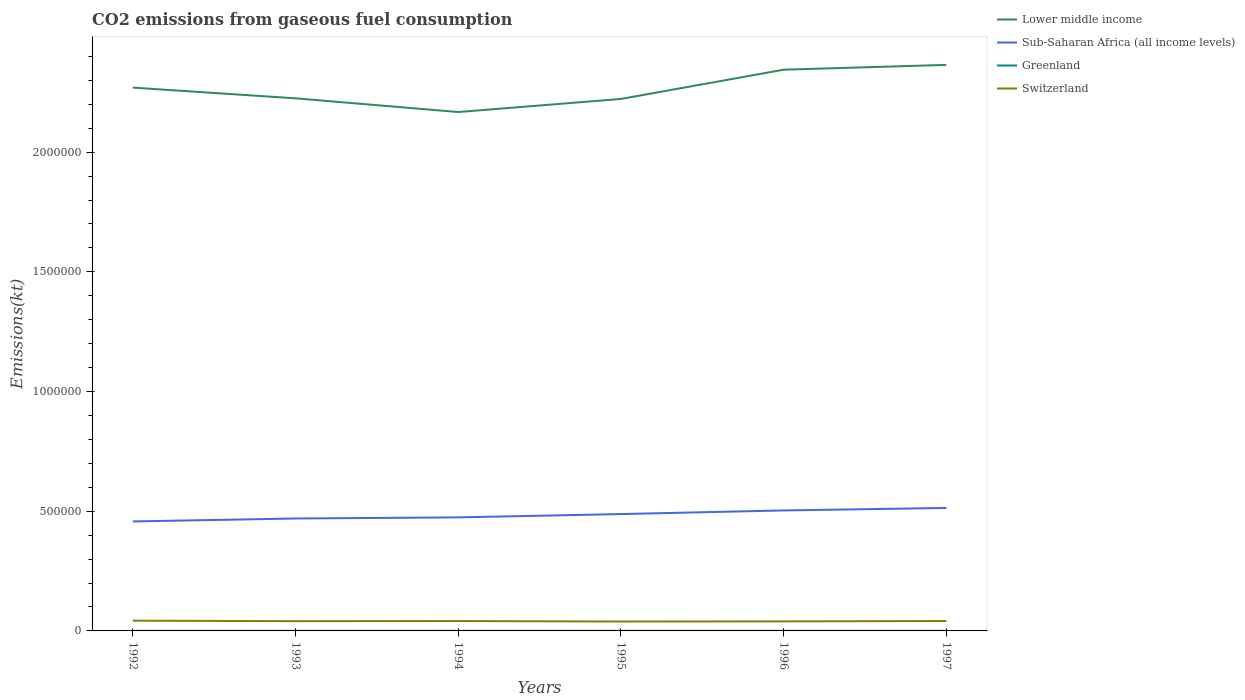How many different coloured lines are there?
Ensure brevity in your answer.  4. Across all years, what is the maximum amount of CO2 emitted in Switzerland?
Your answer should be compact. 3.92e+04. In which year was the amount of CO2 emitted in Switzerland maximum?
Your answer should be very brief. 1995. What is the total amount of CO2 emitted in Switzerland in the graph?
Your answer should be very brief. -143.01. What is the difference between the highest and the second highest amount of CO2 emitted in Switzerland?
Provide a succinct answer. 3567.99. What is the difference between the highest and the lowest amount of CO2 emitted in Lower middle income?
Your answer should be compact. 3. Are the values on the major ticks of Y-axis written in scientific E-notation?
Ensure brevity in your answer.  No. Where does the legend appear in the graph?
Your answer should be compact. Top right. How many legend labels are there?
Offer a terse response. 4. How are the legend labels stacked?
Provide a succinct answer. Vertical. What is the title of the graph?
Your answer should be very brief. CO2 emissions from gaseous fuel consumption. What is the label or title of the Y-axis?
Provide a short and direct response. Emissions(kt). What is the Emissions(kt) in Lower middle income in 1992?
Your answer should be compact. 2.27e+06. What is the Emissions(kt) in Sub-Saharan Africa (all income levels) in 1992?
Offer a very short reply. 4.57e+05. What is the Emissions(kt) of Greenland in 1992?
Provide a succinct answer. 484.04. What is the Emissions(kt) in Switzerland in 1992?
Provide a succinct answer. 4.28e+04. What is the Emissions(kt) in Lower middle income in 1993?
Make the answer very short. 2.22e+06. What is the Emissions(kt) of Sub-Saharan Africa (all income levels) in 1993?
Offer a very short reply. 4.70e+05. What is the Emissions(kt) in Greenland in 1993?
Ensure brevity in your answer.  502.38. What is the Emissions(kt) in Switzerland in 1993?
Provide a short and direct response. 4.08e+04. What is the Emissions(kt) of Lower middle income in 1994?
Ensure brevity in your answer.  2.17e+06. What is the Emissions(kt) in Sub-Saharan Africa (all income levels) in 1994?
Your answer should be compact. 4.74e+05. What is the Emissions(kt) in Greenland in 1994?
Give a very brief answer. 506.05. What is the Emissions(kt) of Switzerland in 1994?
Ensure brevity in your answer.  4.13e+04. What is the Emissions(kt) in Lower middle income in 1995?
Keep it short and to the point. 2.22e+06. What is the Emissions(kt) of Sub-Saharan Africa (all income levels) in 1995?
Offer a very short reply. 4.88e+05. What is the Emissions(kt) in Greenland in 1995?
Your answer should be very brief. 506.05. What is the Emissions(kt) of Switzerland in 1995?
Your answer should be very brief. 3.92e+04. What is the Emissions(kt) of Lower middle income in 1996?
Provide a succinct answer. 2.34e+06. What is the Emissions(kt) of Sub-Saharan Africa (all income levels) in 1996?
Offer a very short reply. 5.03e+05. What is the Emissions(kt) in Greenland in 1996?
Provide a short and direct response. 517.05. What is the Emissions(kt) in Switzerland in 1996?
Ensure brevity in your answer.  3.99e+04. What is the Emissions(kt) of Lower middle income in 1997?
Make the answer very short. 2.36e+06. What is the Emissions(kt) of Sub-Saharan Africa (all income levels) in 1997?
Provide a short and direct response. 5.14e+05. What is the Emissions(kt) of Greenland in 1997?
Give a very brief answer. 524.38. What is the Emissions(kt) of Switzerland in 1997?
Offer a terse response. 4.15e+04. Across all years, what is the maximum Emissions(kt) in Lower middle income?
Your response must be concise. 2.36e+06. Across all years, what is the maximum Emissions(kt) in Sub-Saharan Africa (all income levels)?
Provide a succinct answer. 5.14e+05. Across all years, what is the maximum Emissions(kt) of Greenland?
Provide a short and direct response. 524.38. Across all years, what is the maximum Emissions(kt) in Switzerland?
Offer a very short reply. 4.28e+04. Across all years, what is the minimum Emissions(kt) in Lower middle income?
Provide a short and direct response. 2.17e+06. Across all years, what is the minimum Emissions(kt) in Sub-Saharan Africa (all income levels)?
Offer a very short reply. 4.57e+05. Across all years, what is the minimum Emissions(kt) of Greenland?
Your answer should be very brief. 484.04. Across all years, what is the minimum Emissions(kt) in Switzerland?
Give a very brief answer. 3.92e+04. What is the total Emissions(kt) in Lower middle income in the graph?
Make the answer very short. 1.36e+07. What is the total Emissions(kt) of Sub-Saharan Africa (all income levels) in the graph?
Offer a terse response. 2.91e+06. What is the total Emissions(kt) in Greenland in the graph?
Your answer should be very brief. 3039.94. What is the total Emissions(kt) in Switzerland in the graph?
Your response must be concise. 2.45e+05. What is the difference between the Emissions(kt) of Lower middle income in 1992 and that in 1993?
Keep it short and to the point. 4.48e+04. What is the difference between the Emissions(kt) of Sub-Saharan Africa (all income levels) in 1992 and that in 1993?
Give a very brief answer. -1.22e+04. What is the difference between the Emissions(kt) in Greenland in 1992 and that in 1993?
Provide a short and direct response. -18.34. What is the difference between the Emissions(kt) in Switzerland in 1992 and that in 1993?
Provide a short and direct response. 2042.52. What is the difference between the Emissions(kt) in Lower middle income in 1992 and that in 1994?
Your response must be concise. 1.02e+05. What is the difference between the Emissions(kt) of Sub-Saharan Africa (all income levels) in 1992 and that in 1994?
Give a very brief answer. -1.69e+04. What is the difference between the Emissions(kt) of Greenland in 1992 and that in 1994?
Provide a succinct answer. -22. What is the difference between the Emissions(kt) of Switzerland in 1992 and that in 1994?
Make the answer very short. 1470.47. What is the difference between the Emissions(kt) of Lower middle income in 1992 and that in 1995?
Offer a very short reply. 4.74e+04. What is the difference between the Emissions(kt) in Sub-Saharan Africa (all income levels) in 1992 and that in 1995?
Your response must be concise. -3.08e+04. What is the difference between the Emissions(kt) in Greenland in 1992 and that in 1995?
Ensure brevity in your answer.  -22. What is the difference between the Emissions(kt) of Switzerland in 1992 and that in 1995?
Provide a succinct answer. 3567.99. What is the difference between the Emissions(kt) of Lower middle income in 1992 and that in 1996?
Make the answer very short. -7.47e+04. What is the difference between the Emissions(kt) in Sub-Saharan Africa (all income levels) in 1992 and that in 1996?
Your response must be concise. -4.59e+04. What is the difference between the Emissions(kt) in Greenland in 1992 and that in 1996?
Offer a terse response. -33. What is the difference between the Emissions(kt) in Switzerland in 1992 and that in 1996?
Give a very brief answer. 2907.93. What is the difference between the Emissions(kt) in Lower middle income in 1992 and that in 1997?
Your answer should be compact. -9.50e+04. What is the difference between the Emissions(kt) of Sub-Saharan Africa (all income levels) in 1992 and that in 1997?
Offer a very short reply. -5.63e+04. What is the difference between the Emissions(kt) of Greenland in 1992 and that in 1997?
Your response must be concise. -40.34. What is the difference between the Emissions(kt) of Switzerland in 1992 and that in 1997?
Offer a very short reply. 1327.45. What is the difference between the Emissions(kt) in Lower middle income in 1993 and that in 1994?
Your response must be concise. 5.73e+04. What is the difference between the Emissions(kt) in Sub-Saharan Africa (all income levels) in 1993 and that in 1994?
Your answer should be very brief. -4729.34. What is the difference between the Emissions(kt) in Greenland in 1993 and that in 1994?
Provide a short and direct response. -3.67. What is the difference between the Emissions(kt) in Switzerland in 1993 and that in 1994?
Offer a terse response. -572.05. What is the difference between the Emissions(kt) in Lower middle income in 1993 and that in 1995?
Provide a succinct answer. 2577.5. What is the difference between the Emissions(kt) of Sub-Saharan Africa (all income levels) in 1993 and that in 1995?
Give a very brief answer. -1.86e+04. What is the difference between the Emissions(kt) of Greenland in 1993 and that in 1995?
Ensure brevity in your answer.  -3.67. What is the difference between the Emissions(kt) of Switzerland in 1993 and that in 1995?
Keep it short and to the point. 1525.47. What is the difference between the Emissions(kt) in Lower middle income in 1993 and that in 1996?
Provide a succinct answer. -1.20e+05. What is the difference between the Emissions(kt) of Sub-Saharan Africa (all income levels) in 1993 and that in 1996?
Offer a very short reply. -3.37e+04. What is the difference between the Emissions(kt) of Greenland in 1993 and that in 1996?
Provide a succinct answer. -14.67. What is the difference between the Emissions(kt) in Switzerland in 1993 and that in 1996?
Your response must be concise. 865.41. What is the difference between the Emissions(kt) in Lower middle income in 1993 and that in 1997?
Keep it short and to the point. -1.40e+05. What is the difference between the Emissions(kt) in Sub-Saharan Africa (all income levels) in 1993 and that in 1997?
Offer a terse response. -4.41e+04. What is the difference between the Emissions(kt) in Greenland in 1993 and that in 1997?
Give a very brief answer. -22. What is the difference between the Emissions(kt) in Switzerland in 1993 and that in 1997?
Provide a succinct answer. -715.07. What is the difference between the Emissions(kt) in Lower middle income in 1994 and that in 1995?
Provide a succinct answer. -5.47e+04. What is the difference between the Emissions(kt) in Sub-Saharan Africa (all income levels) in 1994 and that in 1995?
Ensure brevity in your answer.  -1.39e+04. What is the difference between the Emissions(kt) in Switzerland in 1994 and that in 1995?
Make the answer very short. 2097.52. What is the difference between the Emissions(kt) in Lower middle income in 1994 and that in 1996?
Provide a short and direct response. -1.77e+05. What is the difference between the Emissions(kt) of Sub-Saharan Africa (all income levels) in 1994 and that in 1996?
Offer a very short reply. -2.90e+04. What is the difference between the Emissions(kt) in Greenland in 1994 and that in 1996?
Ensure brevity in your answer.  -11. What is the difference between the Emissions(kt) in Switzerland in 1994 and that in 1996?
Offer a terse response. 1437.46. What is the difference between the Emissions(kt) in Lower middle income in 1994 and that in 1997?
Make the answer very short. -1.97e+05. What is the difference between the Emissions(kt) in Sub-Saharan Africa (all income levels) in 1994 and that in 1997?
Make the answer very short. -3.93e+04. What is the difference between the Emissions(kt) of Greenland in 1994 and that in 1997?
Offer a very short reply. -18.34. What is the difference between the Emissions(kt) in Switzerland in 1994 and that in 1997?
Provide a short and direct response. -143.01. What is the difference between the Emissions(kt) in Lower middle income in 1995 and that in 1996?
Provide a succinct answer. -1.22e+05. What is the difference between the Emissions(kt) of Sub-Saharan Africa (all income levels) in 1995 and that in 1996?
Provide a succinct answer. -1.52e+04. What is the difference between the Emissions(kt) in Greenland in 1995 and that in 1996?
Your answer should be very brief. -11. What is the difference between the Emissions(kt) of Switzerland in 1995 and that in 1996?
Your response must be concise. -660.06. What is the difference between the Emissions(kt) of Lower middle income in 1995 and that in 1997?
Your answer should be very brief. -1.42e+05. What is the difference between the Emissions(kt) in Sub-Saharan Africa (all income levels) in 1995 and that in 1997?
Your response must be concise. -2.55e+04. What is the difference between the Emissions(kt) of Greenland in 1995 and that in 1997?
Offer a terse response. -18.34. What is the difference between the Emissions(kt) of Switzerland in 1995 and that in 1997?
Give a very brief answer. -2240.54. What is the difference between the Emissions(kt) of Lower middle income in 1996 and that in 1997?
Make the answer very short. -2.02e+04. What is the difference between the Emissions(kt) of Sub-Saharan Africa (all income levels) in 1996 and that in 1997?
Your answer should be compact. -1.03e+04. What is the difference between the Emissions(kt) in Greenland in 1996 and that in 1997?
Make the answer very short. -7.33. What is the difference between the Emissions(kt) in Switzerland in 1996 and that in 1997?
Provide a short and direct response. -1580.48. What is the difference between the Emissions(kt) in Lower middle income in 1992 and the Emissions(kt) in Sub-Saharan Africa (all income levels) in 1993?
Your answer should be compact. 1.80e+06. What is the difference between the Emissions(kt) in Lower middle income in 1992 and the Emissions(kt) in Greenland in 1993?
Ensure brevity in your answer.  2.27e+06. What is the difference between the Emissions(kt) in Lower middle income in 1992 and the Emissions(kt) in Switzerland in 1993?
Offer a terse response. 2.23e+06. What is the difference between the Emissions(kt) in Sub-Saharan Africa (all income levels) in 1992 and the Emissions(kt) in Greenland in 1993?
Give a very brief answer. 4.57e+05. What is the difference between the Emissions(kt) of Sub-Saharan Africa (all income levels) in 1992 and the Emissions(kt) of Switzerland in 1993?
Your response must be concise. 4.17e+05. What is the difference between the Emissions(kt) in Greenland in 1992 and the Emissions(kt) in Switzerland in 1993?
Your answer should be very brief. -4.03e+04. What is the difference between the Emissions(kt) of Lower middle income in 1992 and the Emissions(kt) of Sub-Saharan Africa (all income levels) in 1994?
Your response must be concise. 1.80e+06. What is the difference between the Emissions(kt) of Lower middle income in 1992 and the Emissions(kt) of Greenland in 1994?
Offer a terse response. 2.27e+06. What is the difference between the Emissions(kt) of Lower middle income in 1992 and the Emissions(kt) of Switzerland in 1994?
Provide a short and direct response. 2.23e+06. What is the difference between the Emissions(kt) of Sub-Saharan Africa (all income levels) in 1992 and the Emissions(kt) of Greenland in 1994?
Ensure brevity in your answer.  4.57e+05. What is the difference between the Emissions(kt) in Sub-Saharan Africa (all income levels) in 1992 and the Emissions(kt) in Switzerland in 1994?
Offer a very short reply. 4.16e+05. What is the difference between the Emissions(kt) in Greenland in 1992 and the Emissions(kt) in Switzerland in 1994?
Your answer should be very brief. -4.08e+04. What is the difference between the Emissions(kt) of Lower middle income in 1992 and the Emissions(kt) of Sub-Saharan Africa (all income levels) in 1995?
Your answer should be compact. 1.78e+06. What is the difference between the Emissions(kt) in Lower middle income in 1992 and the Emissions(kt) in Greenland in 1995?
Keep it short and to the point. 2.27e+06. What is the difference between the Emissions(kt) of Lower middle income in 1992 and the Emissions(kt) of Switzerland in 1995?
Keep it short and to the point. 2.23e+06. What is the difference between the Emissions(kt) in Sub-Saharan Africa (all income levels) in 1992 and the Emissions(kt) in Greenland in 1995?
Your answer should be very brief. 4.57e+05. What is the difference between the Emissions(kt) in Sub-Saharan Africa (all income levels) in 1992 and the Emissions(kt) in Switzerland in 1995?
Offer a terse response. 4.18e+05. What is the difference between the Emissions(kt) of Greenland in 1992 and the Emissions(kt) of Switzerland in 1995?
Offer a terse response. -3.87e+04. What is the difference between the Emissions(kt) of Lower middle income in 1992 and the Emissions(kt) of Sub-Saharan Africa (all income levels) in 1996?
Offer a very short reply. 1.77e+06. What is the difference between the Emissions(kt) in Lower middle income in 1992 and the Emissions(kt) in Greenland in 1996?
Offer a very short reply. 2.27e+06. What is the difference between the Emissions(kt) of Lower middle income in 1992 and the Emissions(kt) of Switzerland in 1996?
Provide a short and direct response. 2.23e+06. What is the difference between the Emissions(kt) in Sub-Saharan Africa (all income levels) in 1992 and the Emissions(kt) in Greenland in 1996?
Offer a terse response. 4.57e+05. What is the difference between the Emissions(kt) in Sub-Saharan Africa (all income levels) in 1992 and the Emissions(kt) in Switzerland in 1996?
Offer a very short reply. 4.17e+05. What is the difference between the Emissions(kt) in Greenland in 1992 and the Emissions(kt) in Switzerland in 1996?
Your answer should be compact. -3.94e+04. What is the difference between the Emissions(kt) of Lower middle income in 1992 and the Emissions(kt) of Sub-Saharan Africa (all income levels) in 1997?
Ensure brevity in your answer.  1.76e+06. What is the difference between the Emissions(kt) of Lower middle income in 1992 and the Emissions(kt) of Greenland in 1997?
Provide a succinct answer. 2.27e+06. What is the difference between the Emissions(kt) of Lower middle income in 1992 and the Emissions(kt) of Switzerland in 1997?
Provide a short and direct response. 2.23e+06. What is the difference between the Emissions(kt) of Sub-Saharan Africa (all income levels) in 1992 and the Emissions(kt) of Greenland in 1997?
Your answer should be very brief. 4.57e+05. What is the difference between the Emissions(kt) of Sub-Saharan Africa (all income levels) in 1992 and the Emissions(kt) of Switzerland in 1997?
Provide a short and direct response. 4.16e+05. What is the difference between the Emissions(kt) of Greenland in 1992 and the Emissions(kt) of Switzerland in 1997?
Your answer should be very brief. -4.10e+04. What is the difference between the Emissions(kt) in Lower middle income in 1993 and the Emissions(kt) in Sub-Saharan Africa (all income levels) in 1994?
Your response must be concise. 1.75e+06. What is the difference between the Emissions(kt) in Lower middle income in 1993 and the Emissions(kt) in Greenland in 1994?
Keep it short and to the point. 2.22e+06. What is the difference between the Emissions(kt) of Lower middle income in 1993 and the Emissions(kt) of Switzerland in 1994?
Make the answer very short. 2.18e+06. What is the difference between the Emissions(kt) in Sub-Saharan Africa (all income levels) in 1993 and the Emissions(kt) in Greenland in 1994?
Keep it short and to the point. 4.69e+05. What is the difference between the Emissions(kt) in Sub-Saharan Africa (all income levels) in 1993 and the Emissions(kt) in Switzerland in 1994?
Make the answer very short. 4.28e+05. What is the difference between the Emissions(kt) in Greenland in 1993 and the Emissions(kt) in Switzerland in 1994?
Ensure brevity in your answer.  -4.08e+04. What is the difference between the Emissions(kt) of Lower middle income in 1993 and the Emissions(kt) of Sub-Saharan Africa (all income levels) in 1995?
Your response must be concise. 1.74e+06. What is the difference between the Emissions(kt) of Lower middle income in 1993 and the Emissions(kt) of Greenland in 1995?
Offer a terse response. 2.22e+06. What is the difference between the Emissions(kt) in Lower middle income in 1993 and the Emissions(kt) in Switzerland in 1995?
Your answer should be compact. 2.19e+06. What is the difference between the Emissions(kt) of Sub-Saharan Africa (all income levels) in 1993 and the Emissions(kt) of Greenland in 1995?
Make the answer very short. 4.69e+05. What is the difference between the Emissions(kt) of Sub-Saharan Africa (all income levels) in 1993 and the Emissions(kt) of Switzerland in 1995?
Your answer should be compact. 4.30e+05. What is the difference between the Emissions(kt) in Greenland in 1993 and the Emissions(kt) in Switzerland in 1995?
Keep it short and to the point. -3.87e+04. What is the difference between the Emissions(kt) in Lower middle income in 1993 and the Emissions(kt) in Sub-Saharan Africa (all income levels) in 1996?
Your answer should be very brief. 1.72e+06. What is the difference between the Emissions(kt) of Lower middle income in 1993 and the Emissions(kt) of Greenland in 1996?
Keep it short and to the point. 2.22e+06. What is the difference between the Emissions(kt) in Lower middle income in 1993 and the Emissions(kt) in Switzerland in 1996?
Your response must be concise. 2.18e+06. What is the difference between the Emissions(kt) in Sub-Saharan Africa (all income levels) in 1993 and the Emissions(kt) in Greenland in 1996?
Offer a very short reply. 4.69e+05. What is the difference between the Emissions(kt) in Sub-Saharan Africa (all income levels) in 1993 and the Emissions(kt) in Switzerland in 1996?
Keep it short and to the point. 4.30e+05. What is the difference between the Emissions(kt) of Greenland in 1993 and the Emissions(kt) of Switzerland in 1996?
Provide a short and direct response. -3.94e+04. What is the difference between the Emissions(kt) in Lower middle income in 1993 and the Emissions(kt) in Sub-Saharan Africa (all income levels) in 1997?
Offer a terse response. 1.71e+06. What is the difference between the Emissions(kt) of Lower middle income in 1993 and the Emissions(kt) of Greenland in 1997?
Make the answer very short. 2.22e+06. What is the difference between the Emissions(kt) in Lower middle income in 1993 and the Emissions(kt) in Switzerland in 1997?
Provide a succinct answer. 2.18e+06. What is the difference between the Emissions(kt) in Sub-Saharan Africa (all income levels) in 1993 and the Emissions(kt) in Greenland in 1997?
Offer a terse response. 4.69e+05. What is the difference between the Emissions(kt) of Sub-Saharan Africa (all income levels) in 1993 and the Emissions(kt) of Switzerland in 1997?
Offer a terse response. 4.28e+05. What is the difference between the Emissions(kt) in Greenland in 1993 and the Emissions(kt) in Switzerland in 1997?
Provide a succinct answer. -4.10e+04. What is the difference between the Emissions(kt) of Lower middle income in 1994 and the Emissions(kt) of Sub-Saharan Africa (all income levels) in 1995?
Offer a very short reply. 1.68e+06. What is the difference between the Emissions(kt) in Lower middle income in 1994 and the Emissions(kt) in Greenland in 1995?
Ensure brevity in your answer.  2.17e+06. What is the difference between the Emissions(kt) in Lower middle income in 1994 and the Emissions(kt) in Switzerland in 1995?
Give a very brief answer. 2.13e+06. What is the difference between the Emissions(kt) in Sub-Saharan Africa (all income levels) in 1994 and the Emissions(kt) in Greenland in 1995?
Ensure brevity in your answer.  4.74e+05. What is the difference between the Emissions(kt) in Sub-Saharan Africa (all income levels) in 1994 and the Emissions(kt) in Switzerland in 1995?
Provide a short and direct response. 4.35e+05. What is the difference between the Emissions(kt) in Greenland in 1994 and the Emissions(kt) in Switzerland in 1995?
Make the answer very short. -3.87e+04. What is the difference between the Emissions(kt) of Lower middle income in 1994 and the Emissions(kt) of Sub-Saharan Africa (all income levels) in 1996?
Provide a short and direct response. 1.66e+06. What is the difference between the Emissions(kt) of Lower middle income in 1994 and the Emissions(kt) of Greenland in 1996?
Ensure brevity in your answer.  2.17e+06. What is the difference between the Emissions(kt) in Lower middle income in 1994 and the Emissions(kt) in Switzerland in 1996?
Provide a succinct answer. 2.13e+06. What is the difference between the Emissions(kt) of Sub-Saharan Africa (all income levels) in 1994 and the Emissions(kt) of Greenland in 1996?
Provide a short and direct response. 4.74e+05. What is the difference between the Emissions(kt) of Sub-Saharan Africa (all income levels) in 1994 and the Emissions(kt) of Switzerland in 1996?
Keep it short and to the point. 4.34e+05. What is the difference between the Emissions(kt) of Greenland in 1994 and the Emissions(kt) of Switzerland in 1996?
Provide a short and direct response. -3.94e+04. What is the difference between the Emissions(kt) in Lower middle income in 1994 and the Emissions(kt) in Sub-Saharan Africa (all income levels) in 1997?
Offer a very short reply. 1.65e+06. What is the difference between the Emissions(kt) of Lower middle income in 1994 and the Emissions(kt) of Greenland in 1997?
Your response must be concise. 2.17e+06. What is the difference between the Emissions(kt) of Lower middle income in 1994 and the Emissions(kt) of Switzerland in 1997?
Keep it short and to the point. 2.13e+06. What is the difference between the Emissions(kt) of Sub-Saharan Africa (all income levels) in 1994 and the Emissions(kt) of Greenland in 1997?
Keep it short and to the point. 4.74e+05. What is the difference between the Emissions(kt) in Sub-Saharan Africa (all income levels) in 1994 and the Emissions(kt) in Switzerland in 1997?
Ensure brevity in your answer.  4.33e+05. What is the difference between the Emissions(kt) in Greenland in 1994 and the Emissions(kt) in Switzerland in 1997?
Provide a short and direct response. -4.10e+04. What is the difference between the Emissions(kt) in Lower middle income in 1995 and the Emissions(kt) in Sub-Saharan Africa (all income levels) in 1996?
Offer a terse response. 1.72e+06. What is the difference between the Emissions(kt) of Lower middle income in 1995 and the Emissions(kt) of Greenland in 1996?
Offer a very short reply. 2.22e+06. What is the difference between the Emissions(kt) in Lower middle income in 1995 and the Emissions(kt) in Switzerland in 1996?
Provide a short and direct response. 2.18e+06. What is the difference between the Emissions(kt) in Sub-Saharan Africa (all income levels) in 1995 and the Emissions(kt) in Greenland in 1996?
Your response must be concise. 4.88e+05. What is the difference between the Emissions(kt) in Sub-Saharan Africa (all income levels) in 1995 and the Emissions(kt) in Switzerland in 1996?
Your response must be concise. 4.48e+05. What is the difference between the Emissions(kt) of Greenland in 1995 and the Emissions(kt) of Switzerland in 1996?
Give a very brief answer. -3.94e+04. What is the difference between the Emissions(kt) of Lower middle income in 1995 and the Emissions(kt) of Sub-Saharan Africa (all income levels) in 1997?
Offer a terse response. 1.71e+06. What is the difference between the Emissions(kt) in Lower middle income in 1995 and the Emissions(kt) in Greenland in 1997?
Provide a succinct answer. 2.22e+06. What is the difference between the Emissions(kt) in Lower middle income in 1995 and the Emissions(kt) in Switzerland in 1997?
Provide a succinct answer. 2.18e+06. What is the difference between the Emissions(kt) of Sub-Saharan Africa (all income levels) in 1995 and the Emissions(kt) of Greenland in 1997?
Offer a very short reply. 4.88e+05. What is the difference between the Emissions(kt) of Sub-Saharan Africa (all income levels) in 1995 and the Emissions(kt) of Switzerland in 1997?
Keep it short and to the point. 4.47e+05. What is the difference between the Emissions(kt) in Greenland in 1995 and the Emissions(kt) in Switzerland in 1997?
Make the answer very short. -4.10e+04. What is the difference between the Emissions(kt) of Lower middle income in 1996 and the Emissions(kt) of Sub-Saharan Africa (all income levels) in 1997?
Your answer should be very brief. 1.83e+06. What is the difference between the Emissions(kt) of Lower middle income in 1996 and the Emissions(kt) of Greenland in 1997?
Make the answer very short. 2.34e+06. What is the difference between the Emissions(kt) of Lower middle income in 1996 and the Emissions(kt) of Switzerland in 1997?
Make the answer very short. 2.30e+06. What is the difference between the Emissions(kt) of Sub-Saharan Africa (all income levels) in 1996 and the Emissions(kt) of Greenland in 1997?
Make the answer very short. 5.03e+05. What is the difference between the Emissions(kt) in Sub-Saharan Africa (all income levels) in 1996 and the Emissions(kt) in Switzerland in 1997?
Your response must be concise. 4.62e+05. What is the difference between the Emissions(kt) of Greenland in 1996 and the Emissions(kt) of Switzerland in 1997?
Give a very brief answer. -4.09e+04. What is the average Emissions(kt) of Lower middle income per year?
Your answer should be very brief. 2.27e+06. What is the average Emissions(kt) in Sub-Saharan Africa (all income levels) per year?
Offer a terse response. 4.84e+05. What is the average Emissions(kt) of Greenland per year?
Offer a terse response. 506.66. What is the average Emissions(kt) in Switzerland per year?
Make the answer very short. 4.09e+04. In the year 1992, what is the difference between the Emissions(kt) of Lower middle income and Emissions(kt) of Sub-Saharan Africa (all income levels)?
Your response must be concise. 1.81e+06. In the year 1992, what is the difference between the Emissions(kt) in Lower middle income and Emissions(kt) in Greenland?
Provide a short and direct response. 2.27e+06. In the year 1992, what is the difference between the Emissions(kt) of Lower middle income and Emissions(kt) of Switzerland?
Offer a very short reply. 2.23e+06. In the year 1992, what is the difference between the Emissions(kt) in Sub-Saharan Africa (all income levels) and Emissions(kt) in Greenland?
Provide a succinct answer. 4.57e+05. In the year 1992, what is the difference between the Emissions(kt) of Sub-Saharan Africa (all income levels) and Emissions(kt) of Switzerland?
Ensure brevity in your answer.  4.15e+05. In the year 1992, what is the difference between the Emissions(kt) of Greenland and Emissions(kt) of Switzerland?
Make the answer very short. -4.23e+04. In the year 1993, what is the difference between the Emissions(kt) of Lower middle income and Emissions(kt) of Sub-Saharan Africa (all income levels)?
Ensure brevity in your answer.  1.76e+06. In the year 1993, what is the difference between the Emissions(kt) of Lower middle income and Emissions(kt) of Greenland?
Give a very brief answer. 2.22e+06. In the year 1993, what is the difference between the Emissions(kt) of Lower middle income and Emissions(kt) of Switzerland?
Give a very brief answer. 2.18e+06. In the year 1993, what is the difference between the Emissions(kt) in Sub-Saharan Africa (all income levels) and Emissions(kt) in Greenland?
Your answer should be very brief. 4.69e+05. In the year 1993, what is the difference between the Emissions(kt) of Sub-Saharan Africa (all income levels) and Emissions(kt) of Switzerland?
Ensure brevity in your answer.  4.29e+05. In the year 1993, what is the difference between the Emissions(kt) in Greenland and Emissions(kt) in Switzerland?
Ensure brevity in your answer.  -4.02e+04. In the year 1994, what is the difference between the Emissions(kt) in Lower middle income and Emissions(kt) in Sub-Saharan Africa (all income levels)?
Your answer should be compact. 1.69e+06. In the year 1994, what is the difference between the Emissions(kt) of Lower middle income and Emissions(kt) of Greenland?
Offer a very short reply. 2.17e+06. In the year 1994, what is the difference between the Emissions(kt) in Lower middle income and Emissions(kt) in Switzerland?
Make the answer very short. 2.13e+06. In the year 1994, what is the difference between the Emissions(kt) in Sub-Saharan Africa (all income levels) and Emissions(kt) in Greenland?
Give a very brief answer. 4.74e+05. In the year 1994, what is the difference between the Emissions(kt) of Sub-Saharan Africa (all income levels) and Emissions(kt) of Switzerland?
Give a very brief answer. 4.33e+05. In the year 1994, what is the difference between the Emissions(kt) of Greenland and Emissions(kt) of Switzerland?
Offer a very short reply. -4.08e+04. In the year 1995, what is the difference between the Emissions(kt) in Lower middle income and Emissions(kt) in Sub-Saharan Africa (all income levels)?
Keep it short and to the point. 1.73e+06. In the year 1995, what is the difference between the Emissions(kt) of Lower middle income and Emissions(kt) of Greenland?
Offer a very short reply. 2.22e+06. In the year 1995, what is the difference between the Emissions(kt) of Lower middle income and Emissions(kt) of Switzerland?
Your answer should be compact. 2.18e+06. In the year 1995, what is the difference between the Emissions(kt) in Sub-Saharan Africa (all income levels) and Emissions(kt) in Greenland?
Offer a terse response. 4.88e+05. In the year 1995, what is the difference between the Emissions(kt) in Sub-Saharan Africa (all income levels) and Emissions(kt) in Switzerland?
Give a very brief answer. 4.49e+05. In the year 1995, what is the difference between the Emissions(kt) of Greenland and Emissions(kt) of Switzerland?
Your answer should be very brief. -3.87e+04. In the year 1996, what is the difference between the Emissions(kt) of Lower middle income and Emissions(kt) of Sub-Saharan Africa (all income levels)?
Ensure brevity in your answer.  1.84e+06. In the year 1996, what is the difference between the Emissions(kt) in Lower middle income and Emissions(kt) in Greenland?
Offer a terse response. 2.34e+06. In the year 1996, what is the difference between the Emissions(kt) in Lower middle income and Emissions(kt) in Switzerland?
Ensure brevity in your answer.  2.30e+06. In the year 1996, what is the difference between the Emissions(kt) in Sub-Saharan Africa (all income levels) and Emissions(kt) in Greenland?
Make the answer very short. 5.03e+05. In the year 1996, what is the difference between the Emissions(kt) of Sub-Saharan Africa (all income levels) and Emissions(kt) of Switzerland?
Offer a very short reply. 4.63e+05. In the year 1996, what is the difference between the Emissions(kt) of Greenland and Emissions(kt) of Switzerland?
Provide a succinct answer. -3.94e+04. In the year 1997, what is the difference between the Emissions(kt) of Lower middle income and Emissions(kt) of Sub-Saharan Africa (all income levels)?
Keep it short and to the point. 1.85e+06. In the year 1997, what is the difference between the Emissions(kt) in Lower middle income and Emissions(kt) in Greenland?
Give a very brief answer. 2.36e+06. In the year 1997, what is the difference between the Emissions(kt) of Lower middle income and Emissions(kt) of Switzerland?
Offer a terse response. 2.32e+06. In the year 1997, what is the difference between the Emissions(kt) in Sub-Saharan Africa (all income levels) and Emissions(kt) in Greenland?
Your answer should be very brief. 5.13e+05. In the year 1997, what is the difference between the Emissions(kt) in Sub-Saharan Africa (all income levels) and Emissions(kt) in Switzerland?
Keep it short and to the point. 4.72e+05. In the year 1997, what is the difference between the Emissions(kt) of Greenland and Emissions(kt) of Switzerland?
Provide a short and direct response. -4.09e+04. What is the ratio of the Emissions(kt) in Lower middle income in 1992 to that in 1993?
Your response must be concise. 1.02. What is the ratio of the Emissions(kt) of Greenland in 1992 to that in 1993?
Make the answer very short. 0.96. What is the ratio of the Emissions(kt) in Switzerland in 1992 to that in 1993?
Your answer should be very brief. 1.05. What is the ratio of the Emissions(kt) of Lower middle income in 1992 to that in 1994?
Provide a succinct answer. 1.05. What is the ratio of the Emissions(kt) of Sub-Saharan Africa (all income levels) in 1992 to that in 1994?
Provide a succinct answer. 0.96. What is the ratio of the Emissions(kt) of Greenland in 1992 to that in 1994?
Give a very brief answer. 0.96. What is the ratio of the Emissions(kt) of Switzerland in 1992 to that in 1994?
Offer a very short reply. 1.04. What is the ratio of the Emissions(kt) of Lower middle income in 1992 to that in 1995?
Provide a short and direct response. 1.02. What is the ratio of the Emissions(kt) of Sub-Saharan Africa (all income levels) in 1992 to that in 1995?
Provide a succinct answer. 0.94. What is the ratio of the Emissions(kt) in Greenland in 1992 to that in 1995?
Make the answer very short. 0.96. What is the ratio of the Emissions(kt) of Switzerland in 1992 to that in 1995?
Your answer should be very brief. 1.09. What is the ratio of the Emissions(kt) in Lower middle income in 1992 to that in 1996?
Ensure brevity in your answer.  0.97. What is the ratio of the Emissions(kt) in Sub-Saharan Africa (all income levels) in 1992 to that in 1996?
Your response must be concise. 0.91. What is the ratio of the Emissions(kt) of Greenland in 1992 to that in 1996?
Give a very brief answer. 0.94. What is the ratio of the Emissions(kt) in Switzerland in 1992 to that in 1996?
Offer a very short reply. 1.07. What is the ratio of the Emissions(kt) in Lower middle income in 1992 to that in 1997?
Ensure brevity in your answer.  0.96. What is the ratio of the Emissions(kt) of Sub-Saharan Africa (all income levels) in 1992 to that in 1997?
Your answer should be compact. 0.89. What is the ratio of the Emissions(kt) of Switzerland in 1992 to that in 1997?
Your answer should be compact. 1.03. What is the ratio of the Emissions(kt) in Lower middle income in 1993 to that in 1994?
Ensure brevity in your answer.  1.03. What is the ratio of the Emissions(kt) of Sub-Saharan Africa (all income levels) in 1993 to that in 1994?
Your response must be concise. 0.99. What is the ratio of the Emissions(kt) of Switzerland in 1993 to that in 1994?
Your response must be concise. 0.99. What is the ratio of the Emissions(kt) of Sub-Saharan Africa (all income levels) in 1993 to that in 1995?
Offer a terse response. 0.96. What is the ratio of the Emissions(kt) in Switzerland in 1993 to that in 1995?
Offer a terse response. 1.04. What is the ratio of the Emissions(kt) in Lower middle income in 1993 to that in 1996?
Make the answer very short. 0.95. What is the ratio of the Emissions(kt) in Sub-Saharan Africa (all income levels) in 1993 to that in 1996?
Give a very brief answer. 0.93. What is the ratio of the Emissions(kt) of Greenland in 1993 to that in 1996?
Offer a terse response. 0.97. What is the ratio of the Emissions(kt) of Switzerland in 1993 to that in 1996?
Your response must be concise. 1.02. What is the ratio of the Emissions(kt) in Lower middle income in 1993 to that in 1997?
Provide a succinct answer. 0.94. What is the ratio of the Emissions(kt) in Sub-Saharan Africa (all income levels) in 1993 to that in 1997?
Provide a short and direct response. 0.91. What is the ratio of the Emissions(kt) of Greenland in 1993 to that in 1997?
Your response must be concise. 0.96. What is the ratio of the Emissions(kt) of Switzerland in 1993 to that in 1997?
Your answer should be compact. 0.98. What is the ratio of the Emissions(kt) in Lower middle income in 1994 to that in 1995?
Provide a succinct answer. 0.98. What is the ratio of the Emissions(kt) of Sub-Saharan Africa (all income levels) in 1994 to that in 1995?
Provide a succinct answer. 0.97. What is the ratio of the Emissions(kt) of Switzerland in 1994 to that in 1995?
Offer a terse response. 1.05. What is the ratio of the Emissions(kt) of Lower middle income in 1994 to that in 1996?
Your answer should be very brief. 0.92. What is the ratio of the Emissions(kt) in Sub-Saharan Africa (all income levels) in 1994 to that in 1996?
Keep it short and to the point. 0.94. What is the ratio of the Emissions(kt) in Greenland in 1994 to that in 1996?
Your answer should be very brief. 0.98. What is the ratio of the Emissions(kt) in Switzerland in 1994 to that in 1996?
Keep it short and to the point. 1.04. What is the ratio of the Emissions(kt) in Lower middle income in 1994 to that in 1997?
Provide a short and direct response. 0.92. What is the ratio of the Emissions(kt) of Sub-Saharan Africa (all income levels) in 1994 to that in 1997?
Make the answer very short. 0.92. What is the ratio of the Emissions(kt) of Greenland in 1994 to that in 1997?
Provide a short and direct response. 0.96. What is the ratio of the Emissions(kt) of Lower middle income in 1995 to that in 1996?
Offer a very short reply. 0.95. What is the ratio of the Emissions(kt) of Sub-Saharan Africa (all income levels) in 1995 to that in 1996?
Your response must be concise. 0.97. What is the ratio of the Emissions(kt) of Greenland in 1995 to that in 1996?
Provide a short and direct response. 0.98. What is the ratio of the Emissions(kt) in Switzerland in 1995 to that in 1996?
Offer a terse response. 0.98. What is the ratio of the Emissions(kt) of Lower middle income in 1995 to that in 1997?
Provide a short and direct response. 0.94. What is the ratio of the Emissions(kt) of Sub-Saharan Africa (all income levels) in 1995 to that in 1997?
Offer a very short reply. 0.95. What is the ratio of the Emissions(kt) in Greenland in 1995 to that in 1997?
Give a very brief answer. 0.96. What is the ratio of the Emissions(kt) of Switzerland in 1995 to that in 1997?
Ensure brevity in your answer.  0.95. What is the ratio of the Emissions(kt) in Lower middle income in 1996 to that in 1997?
Offer a terse response. 0.99. What is the ratio of the Emissions(kt) in Sub-Saharan Africa (all income levels) in 1996 to that in 1997?
Keep it short and to the point. 0.98. What is the ratio of the Emissions(kt) of Greenland in 1996 to that in 1997?
Ensure brevity in your answer.  0.99. What is the ratio of the Emissions(kt) of Switzerland in 1996 to that in 1997?
Offer a terse response. 0.96. What is the difference between the highest and the second highest Emissions(kt) in Lower middle income?
Make the answer very short. 2.02e+04. What is the difference between the highest and the second highest Emissions(kt) in Sub-Saharan Africa (all income levels)?
Offer a terse response. 1.03e+04. What is the difference between the highest and the second highest Emissions(kt) of Greenland?
Your answer should be compact. 7.33. What is the difference between the highest and the second highest Emissions(kt) in Switzerland?
Provide a succinct answer. 1327.45. What is the difference between the highest and the lowest Emissions(kt) in Lower middle income?
Ensure brevity in your answer.  1.97e+05. What is the difference between the highest and the lowest Emissions(kt) of Sub-Saharan Africa (all income levels)?
Provide a short and direct response. 5.63e+04. What is the difference between the highest and the lowest Emissions(kt) of Greenland?
Provide a short and direct response. 40.34. What is the difference between the highest and the lowest Emissions(kt) of Switzerland?
Your answer should be very brief. 3567.99. 